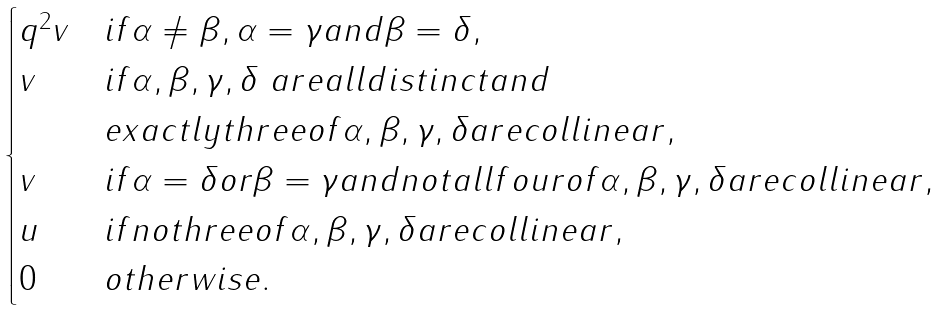Convert formula to latex. <formula><loc_0><loc_0><loc_500><loc_500>\begin{cases} q ^ { 2 } v & i f \alpha \neq \beta , \alpha = \gamma a n d \beta = \delta , \\ v & i f \alpha , \beta , \gamma , \delta \ a r e a l l d i s t i n c t a n d \\ & e x a c t l y t h r e e o f \alpha , \beta , \gamma , \delta a r e c o l l i n e a r , \\ v & i f \alpha = \delta o r \beta = \gamma a n d n o t a l l f o u r o f \alpha , \beta , \gamma , \delta a r e c o l l i n e a r , \\ u & i f n o t h r e e o f \alpha , \beta , \gamma , \delta a r e c o l l i n e a r , \\ 0 & o t h e r w i s e . \end{cases}</formula> 